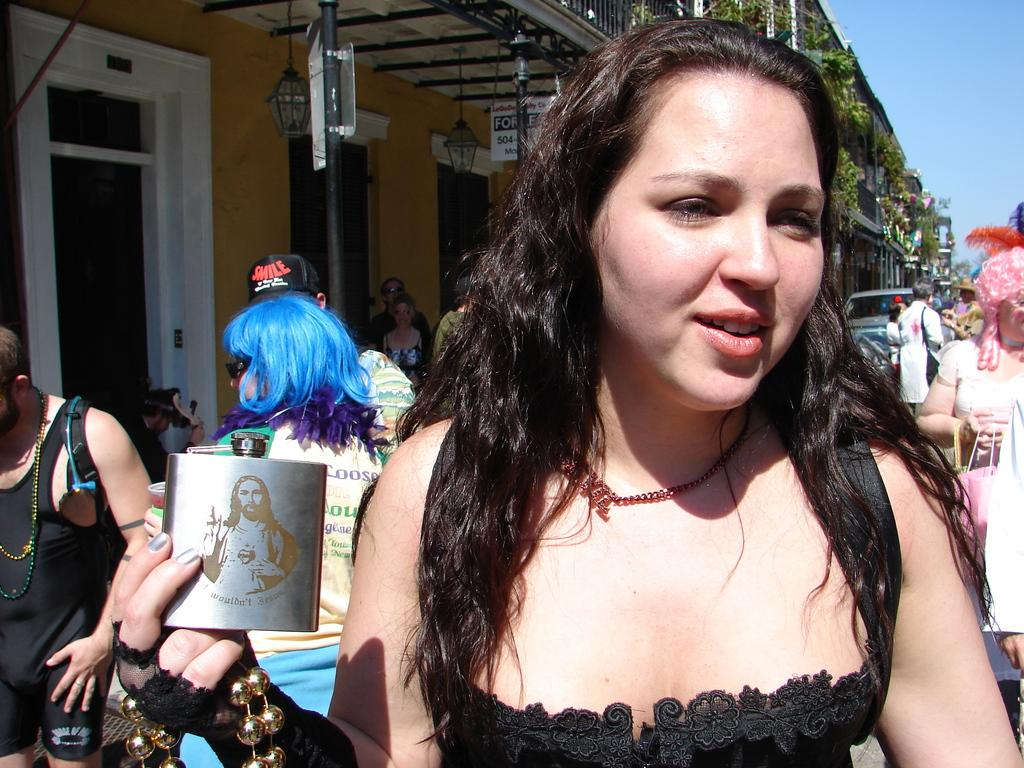What are the people in the image doing? The people in the image are walking on a road. What is the woman holding in her hand? The woman is holding a bottle in her hand. What can be seen in the background of the image? There is a building and the sky visible in the background of the image. What type of skirt is the woman wearing in the image? There is no information about the woman's skirt in the image, as the focus is on her holding a bottle. 